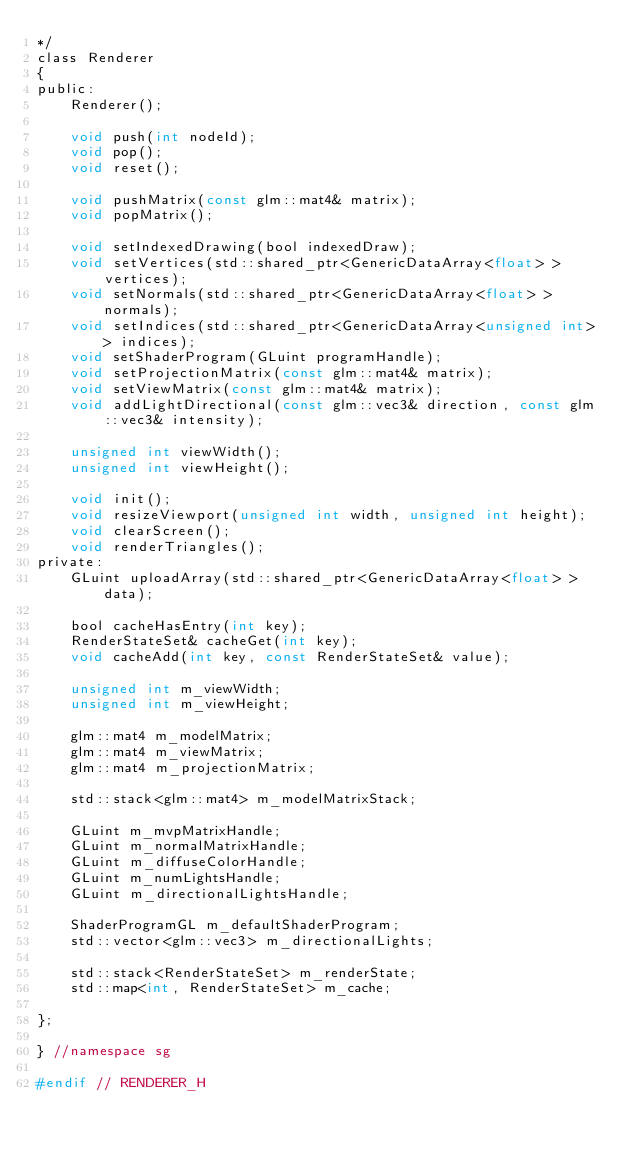Convert code to text. <code><loc_0><loc_0><loc_500><loc_500><_C_>*/
class Renderer
{
public:
	Renderer();

	void push(int nodeId);
	void pop();
    void reset();

	void pushMatrix(const glm::mat4& matrix);
	void popMatrix();

	void setIndexedDrawing(bool indexedDraw);
	void setVertices(std::shared_ptr<GenericDataArray<float> > vertices);
	void setNormals(std::shared_ptr<GenericDataArray<float> > normals);
	void setIndices(std::shared_ptr<GenericDataArray<unsigned int> > indices);
	void setShaderProgram(GLuint programHandle);
	void setProjectionMatrix(const glm::mat4& matrix);
	void setViewMatrix(const glm::mat4& matrix);
	void addLightDirectional(const glm::vec3& direction, const glm::vec3& intensity);

	unsigned int viewWidth();
	unsigned int viewHeight();

	void init();
	void resizeViewport(unsigned int width, unsigned int height);
	void clearScreen();
	void renderTriangles();
private:
    GLuint uploadArray(std::shared_ptr<GenericDataArray<float> > data);

	bool cacheHasEntry(int key);
	RenderStateSet& cacheGet(int key);
	void cacheAdd(int key, const RenderStateSet& value);

	unsigned int m_viewWidth;
	unsigned int m_viewHeight;

	glm::mat4 m_modelMatrix;
	glm::mat4 m_viewMatrix;
	glm::mat4 m_projectionMatrix;

	std::stack<glm::mat4> m_modelMatrixStack;

	GLuint m_mvpMatrixHandle;
	GLuint m_normalMatrixHandle;
	GLuint m_diffuseColorHandle;
	GLuint m_numLightsHandle;
	GLuint m_directionalLightsHandle;

	ShaderProgramGL m_defaultShaderProgram;
	std::vector<glm::vec3> m_directionalLights;

	std::stack<RenderStateSet> m_renderState;
    std::map<int, RenderStateSet> m_cache;

};

} //namespace sg

#endif // RENDERER_H</code> 